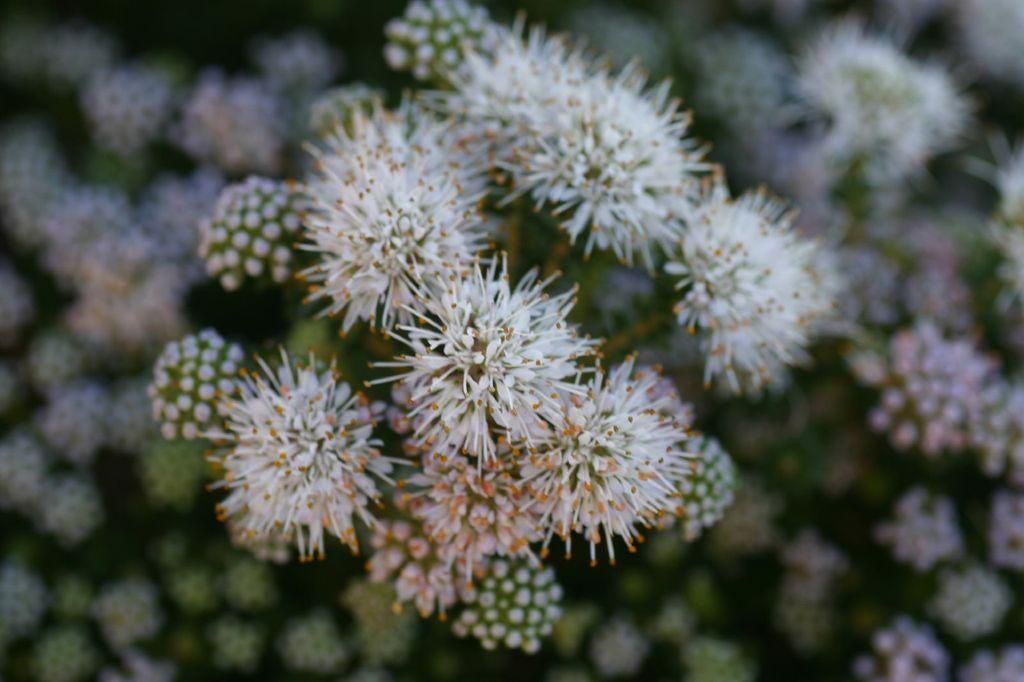What type of flowers are present in the image? There are white colored flowers in the image. Can you describe the background of the image? The backdrop is blurred. What is the price of the gold ornament in the image? There is no gold ornament present in the image, so it is not possible to determine its price. 